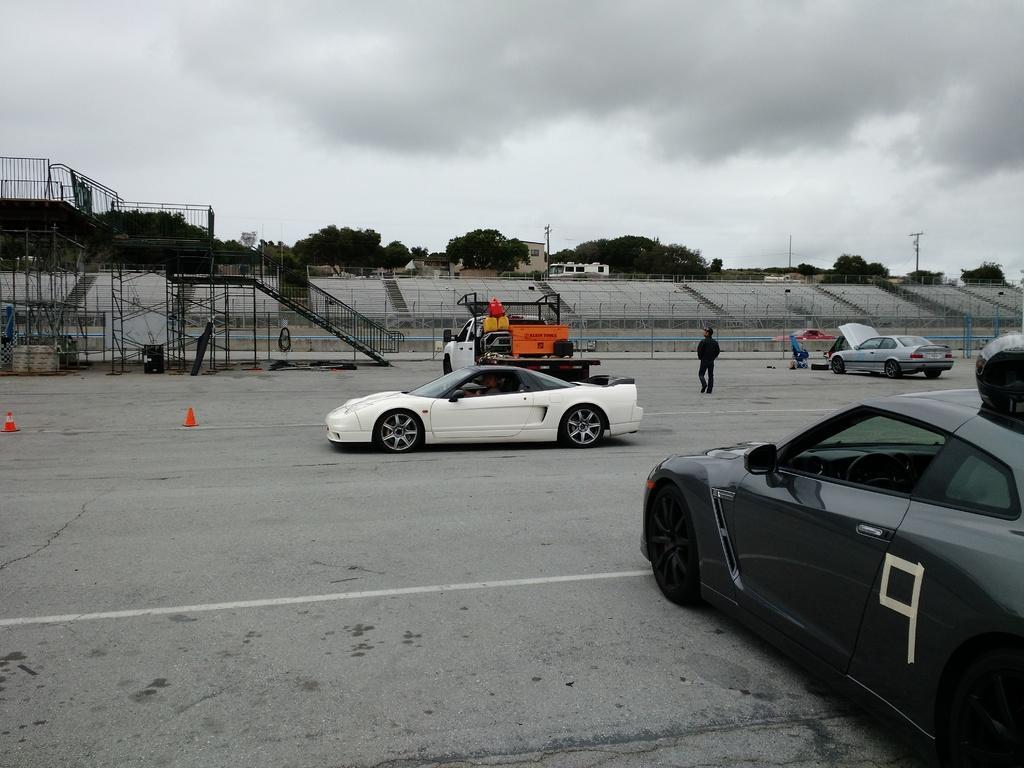Describe this image in one or two sentences. In this image there are some vehicles and some persons, at the bottom there is a walkway and some barricades. And in the background there are some trees, poles, wires and some iron rods and iron poles and some objects. At the top there is sky. 